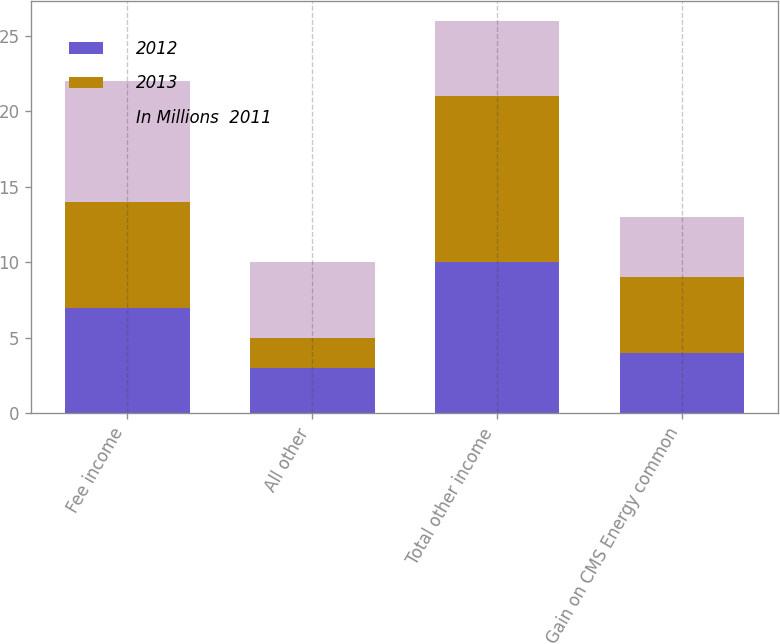Convert chart to OTSL. <chart><loc_0><loc_0><loc_500><loc_500><stacked_bar_chart><ecel><fcel>Fee income<fcel>All other<fcel>Total other income<fcel>Gain on CMS Energy common<nl><fcel>2012<fcel>7<fcel>3<fcel>10<fcel>4<nl><fcel>2013<fcel>7<fcel>2<fcel>11<fcel>5<nl><fcel>In Millions  2011<fcel>8<fcel>5<fcel>5<fcel>4<nl></chart> 